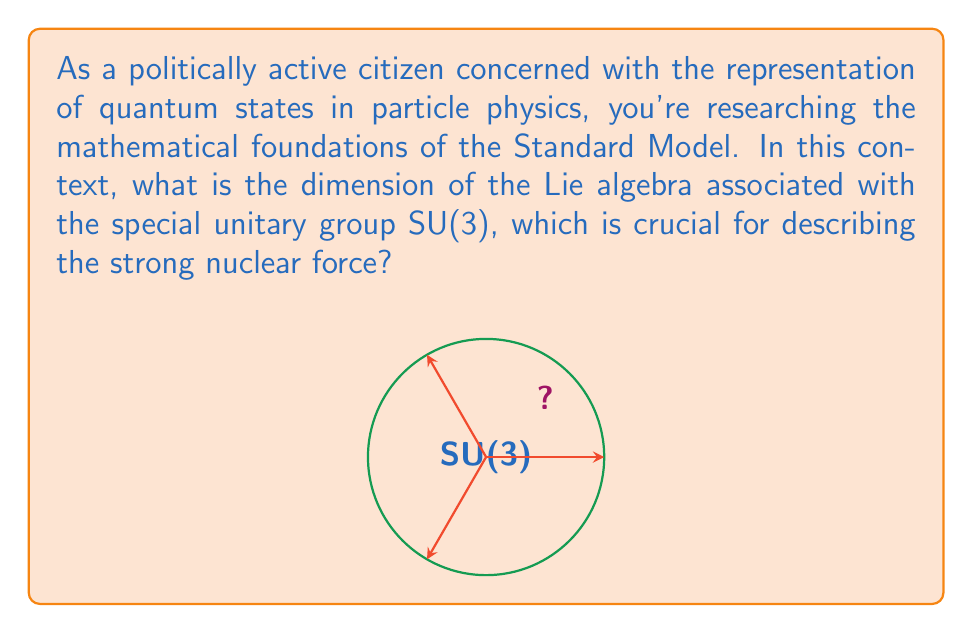Help me with this question. To find the dimension of the Lie algebra associated with SU(3), we can follow these steps:

1) SU(3) is the special unitary group of 3×3 matrices. These matrices $U$ satisfy:
   $$U U^\dagger = U^\dagger U = I \text{ and } \det(U) = 1$$

2) The Lie algebra $\mathfrak{su}(3)$ consists of 3×3 matrices $X$ such that:
   $$e^{iX} \in \text{SU}(3)$$

3) For small $t$, we can approximate:
   $$e^{itX} \approx I + itX$$

4) For this to be unitary, we need:
   $$(I + itX)(I - itX^\dagger) \approx I$$
   
   This implies $X + X^\dagger = 0$, or $X$ is anti-Hermitian.

5) For the determinant to be 1, we need:
   $$\text{Tr}(X) = 0$$

6) A general 3×3 complex matrix has 18 real parameters (9 complex numbers).

7) The anti-Hermitian condition gives us 9 constraints (3 on the diagonal must be pure imaginary, 3 below the diagonal determine those above).

8) The trace zero condition gives 1 more constraint.

9) Therefore, the number of free parameters, which is the dimension of $\mathfrak{su}(3)$, is:
   $$18 - 9 - 1 = 8$$

Thus, the dimension of the Lie algebra $\mathfrak{su}(3)$ associated with SU(3) is 8.
Answer: 8 